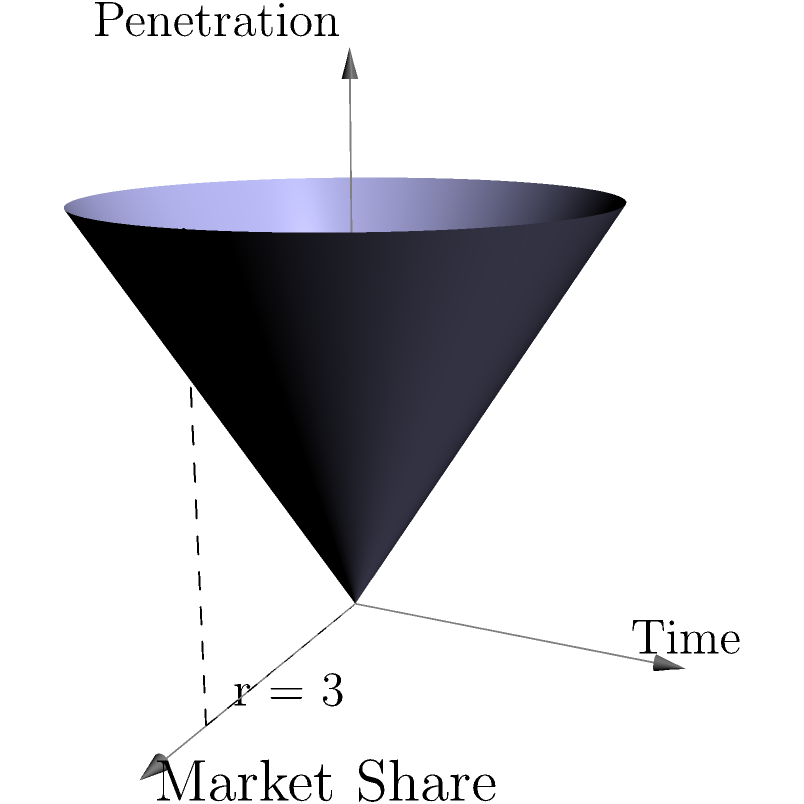As a tech entrepreneur, you're analyzing market penetration data for a new product. The data is represented by a cone, where the base radius represents market share, the height represents time, and the volume represents overall market penetration. Given a base radius of 3 units and a height of 3 units, calculate the volume of the cone to determine the total market penetration over time. Round your answer to two decimal places. To solve this problem, we'll use the formula for the volume of a cone and apply it to our market penetration model:

1. The formula for the volume of a cone is:
   $$V = \frac{1}{3}\pi r^2 h$$
   Where:
   $V$ = volume
   $r$ = radius of the base
   $h$ = height of the cone

2. We're given:
   $r = 3$ units (market share)
   $h = 3$ units (time)

3. Let's substitute these values into our formula:
   $$V = \frac{1}{3}\pi (3)^2 (3)$$

4. Simplify:
   $$V = \frac{1}{3}\pi (9) (3)$$
   $$V = \pi (9)$$

5. Calculate:
   $$V = 28.27433...$$

6. Rounding to two decimal places:
   $$V \approx 28.27$$

Therefore, the total market penetration over time, represented by the volume of the cone, is approximately 28.27 cubic units.
Answer: 28.27 cubic units 